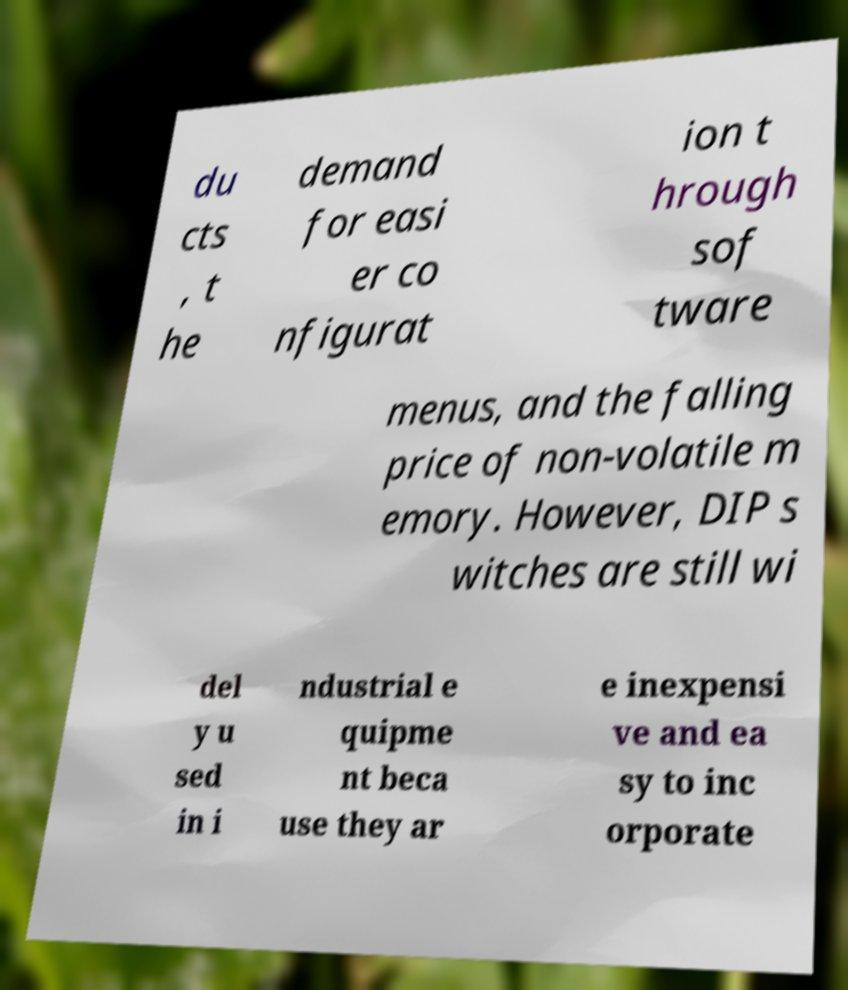I need the written content from this picture converted into text. Can you do that? du cts , t he demand for easi er co nfigurat ion t hrough sof tware menus, and the falling price of non-volatile m emory. However, DIP s witches are still wi del y u sed in i ndustrial e quipme nt beca use they ar e inexpensi ve and ea sy to inc orporate 